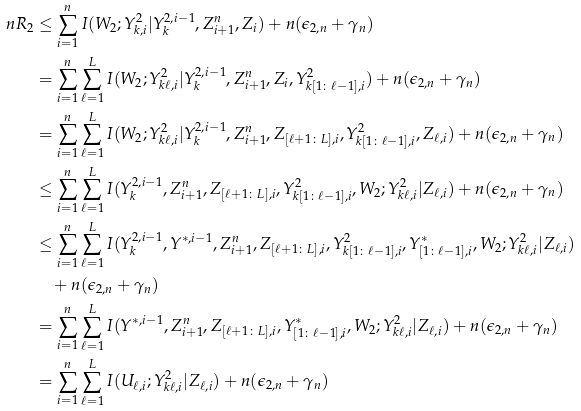Convert formula to latex. <formula><loc_0><loc_0><loc_500><loc_500>n R _ { 2 } & \leq \sum _ { i = 1 } ^ { n } I ( W _ { 2 } ; Y _ { k , i } ^ { 2 } | Y _ { k } ^ { 2 , i - 1 } , Z _ { i + 1 } ^ { n } , Z _ { i } ) + n ( \epsilon _ { 2 , n } + \gamma _ { n } ) \\ & = \sum _ { i = 1 } ^ { n } \sum _ { \ell = 1 } ^ { L } I ( W _ { 2 } ; Y _ { k \ell , i } ^ { 2 } | Y _ { k } ^ { 2 , i - 1 } , Z _ { i + 1 } ^ { n } , Z _ { i } , Y _ { k [ 1 \colon \ell - 1 ] , i } ^ { 2 } ) + n ( \epsilon _ { 2 , n } + \gamma _ { n } ) \\ & = \sum _ { i = 1 } ^ { n } \sum _ { \ell = 1 } ^ { L } I ( W _ { 2 } ; Y _ { k \ell , i } ^ { 2 } | Y _ { k } ^ { 2 , i - 1 } , Z _ { i + 1 } ^ { n } , Z _ { [ \ell + 1 \colon L ] , i } , Y _ { k [ 1 \colon \ell - 1 ] , i } ^ { 2 } , Z _ { \ell , i } ) + n ( \epsilon _ { 2 , n } + \gamma _ { n } ) \\ & \leq \sum _ { i = 1 } ^ { n } \sum _ { \ell = 1 } ^ { L } I ( Y _ { k } ^ { 2 , i - 1 } , Z _ { i + 1 } ^ { n } , Z _ { [ \ell + 1 \colon L ] , i } , Y _ { k [ 1 \colon \ell - 1 ] , i } ^ { 2 } , W _ { 2 } ; Y _ { k \ell , i } ^ { 2 } | Z _ { \ell , i } ) + n ( \epsilon _ { 2 , n } + \gamma _ { n } ) \\ & \leq \sum _ { i = 1 } ^ { n } \sum _ { \ell = 1 } ^ { L } I ( Y _ { k } ^ { 2 , i - 1 } , Y ^ { * , i - 1 } , Z _ { i + 1 } ^ { n } , Z _ { [ \ell + 1 \colon L ] , i } , Y _ { k [ 1 \colon \ell - 1 ] , i } ^ { 2 } , Y ^ { * } _ { [ 1 \colon \ell - 1 ] , i } , W _ { 2 } ; Y _ { k \ell , i } ^ { 2 } | Z _ { \ell , i } ) \\ & \quad + n ( \epsilon _ { 2 , n } + \gamma _ { n } ) \\ & = \sum _ { i = 1 } ^ { n } \sum _ { \ell = 1 } ^ { L } I ( Y ^ { * , i - 1 } , Z _ { i + 1 } ^ { n } , Z _ { [ \ell + 1 \colon L ] , i } , Y ^ { * } _ { [ 1 \colon \ell - 1 ] , i } , W _ { 2 } ; Y _ { k \ell , i } ^ { 2 } | Z _ { \ell , i } ) + n ( \epsilon _ { 2 , n } + \gamma _ { n } ) \\ & = \sum _ { i = 1 } ^ { n } \sum _ { \ell = 1 } ^ { L } I ( U _ { \ell , i } ; Y _ { k \ell , i } ^ { 2 } | Z _ { \ell , i } ) + n ( \epsilon _ { 2 , n } + \gamma _ { n } )</formula> 